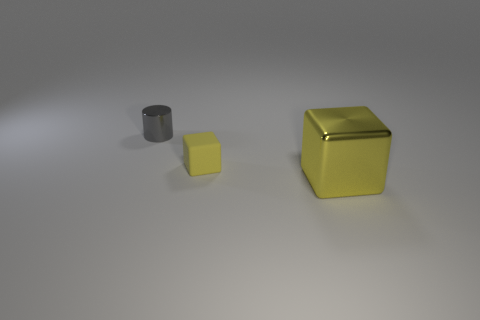Add 3 tiny blocks. How many objects exist? 6 Subtract all cylinders. How many objects are left? 2 Subtract all purple cubes. Subtract all green spheres. How many cubes are left? 2 Subtract all gray blocks. Subtract all yellow blocks. How many objects are left? 1 Add 2 big cubes. How many big cubes are left? 3 Add 1 big gray rubber cylinders. How many big gray rubber cylinders exist? 1 Subtract 0 cyan blocks. How many objects are left? 3 